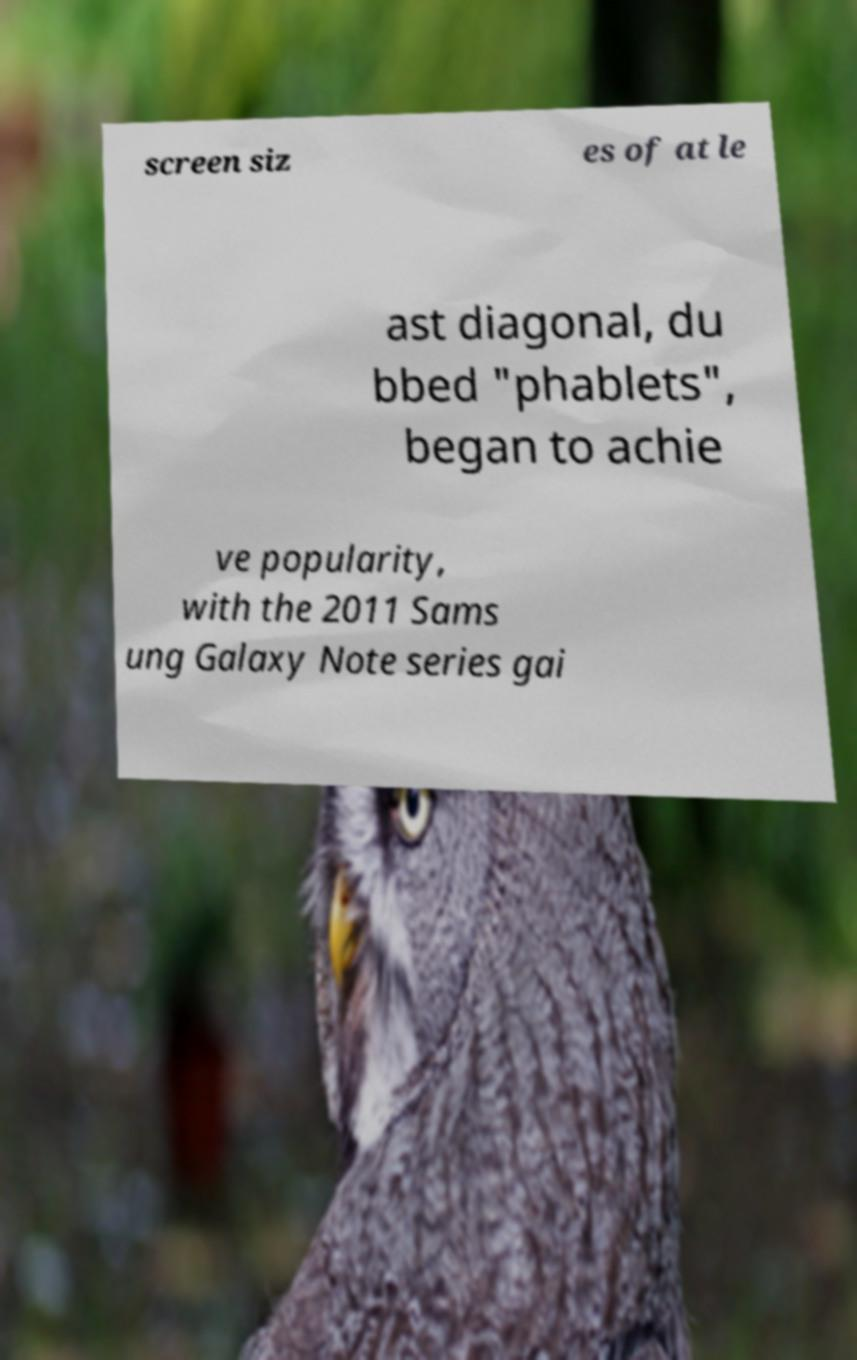There's text embedded in this image that I need extracted. Can you transcribe it verbatim? screen siz es of at le ast diagonal, du bbed "phablets", began to achie ve popularity, with the 2011 Sams ung Galaxy Note series gai 